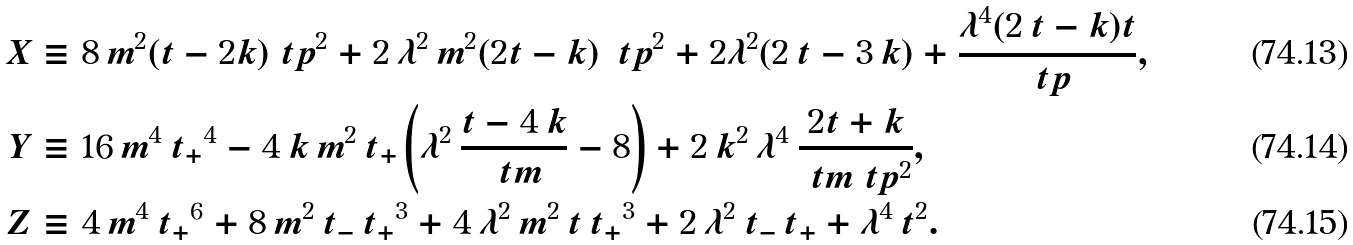Convert formula to latex. <formula><loc_0><loc_0><loc_500><loc_500>X & \equiv 8 \, m ^ { 2 } ( t - 2 k ) { \ t p } ^ { 2 } + 2 \, { \lambda } ^ { 2 } \, m ^ { 2 } ( 2 t - k ) \, { \ t p } ^ { 2 } + 2 { \lambda } ^ { 2 } ( 2 \, t - 3 \, k ) + \frac { { \lambda } ^ { 4 } ( 2 \, t - k ) t } { \ t p } , \\ Y & \equiv 1 6 \, m ^ { 4 } \, { t _ { + } } ^ { 4 } - 4 \, k \, m ^ { 2 } \, { t _ { + } } \left ( { \lambda } ^ { 2 } \, \frac { t - 4 \, k } { \ t m } - 8 \right ) + 2 \, k ^ { 2 } \, { \lambda } ^ { 4 } \, \frac { 2 t + k } { \ t m \ t p ^ { 2 } } , \\ Z & \equiv 4 \, m ^ { 4 } \, { t _ { + } } ^ { 6 } + 8 \, m ^ { 2 } \, { t _ { - } } \, { t _ { + } } ^ { 3 } + 4 \, { \lambda } ^ { 2 } \, m ^ { 2 } \, t \, { t _ { + } } ^ { 3 } + 2 \, { \lambda } ^ { 2 } \, { t _ { - } } \, { t _ { + } } + { \lambda } ^ { 4 } \, t ^ { 2 } .</formula> 